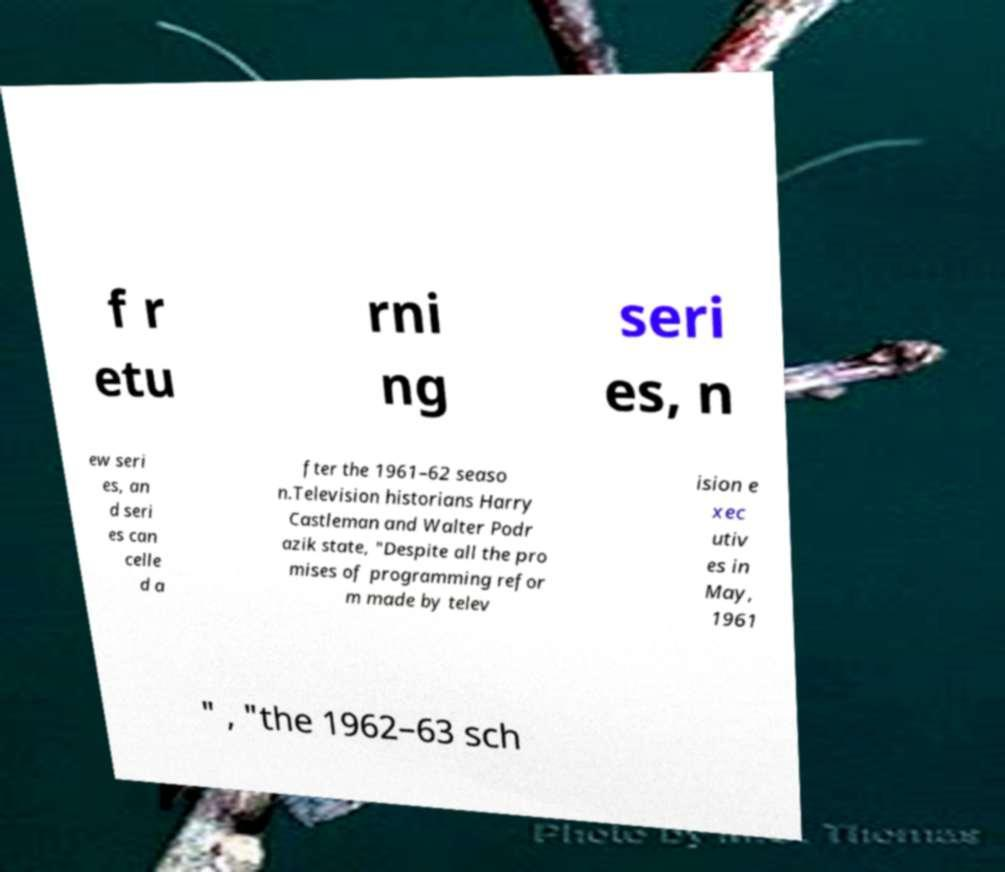Please identify and transcribe the text found in this image. f r etu rni ng seri es, n ew seri es, an d seri es can celle d a fter the 1961–62 seaso n.Television historians Harry Castleman and Walter Podr azik state, "Despite all the pro mises of programming refor m made by telev ision e xec utiv es in May, 1961 " , "the 1962–63 sch 